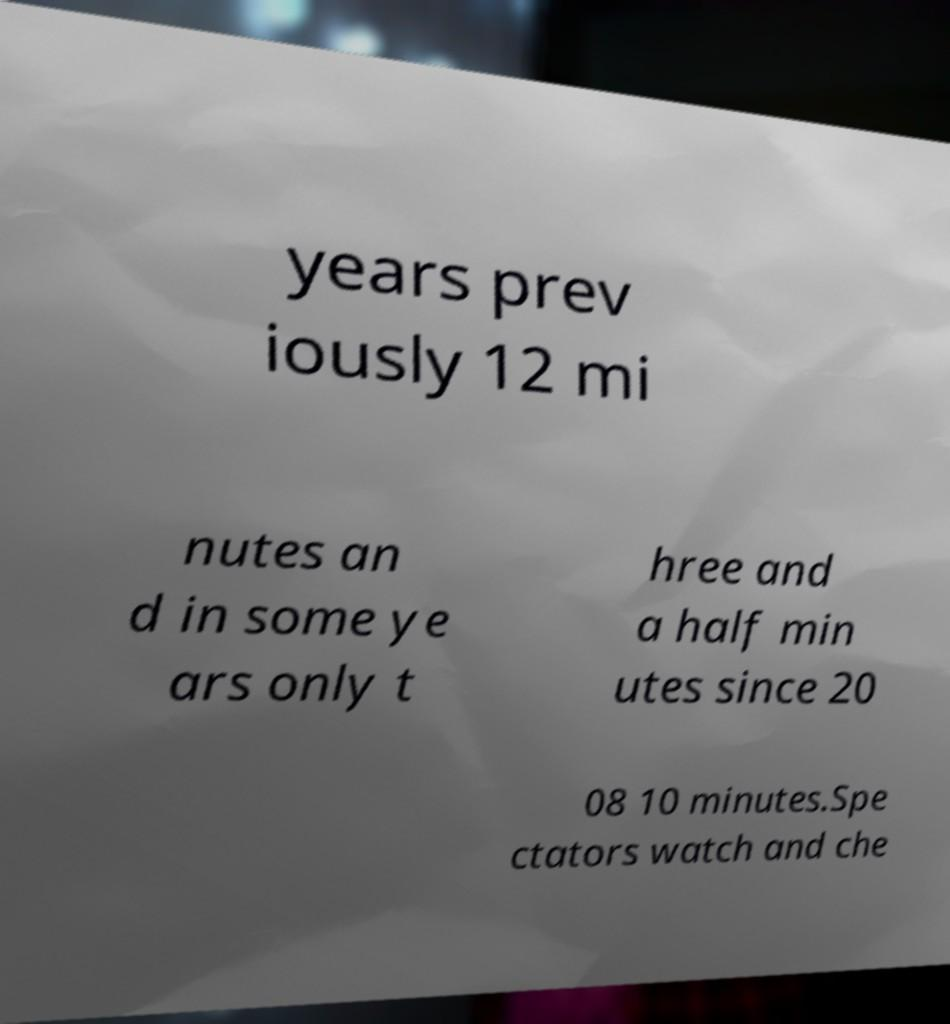Could you extract and type out the text from this image? years prev iously 12 mi nutes an d in some ye ars only t hree and a half min utes since 20 08 10 minutes.Spe ctators watch and che 